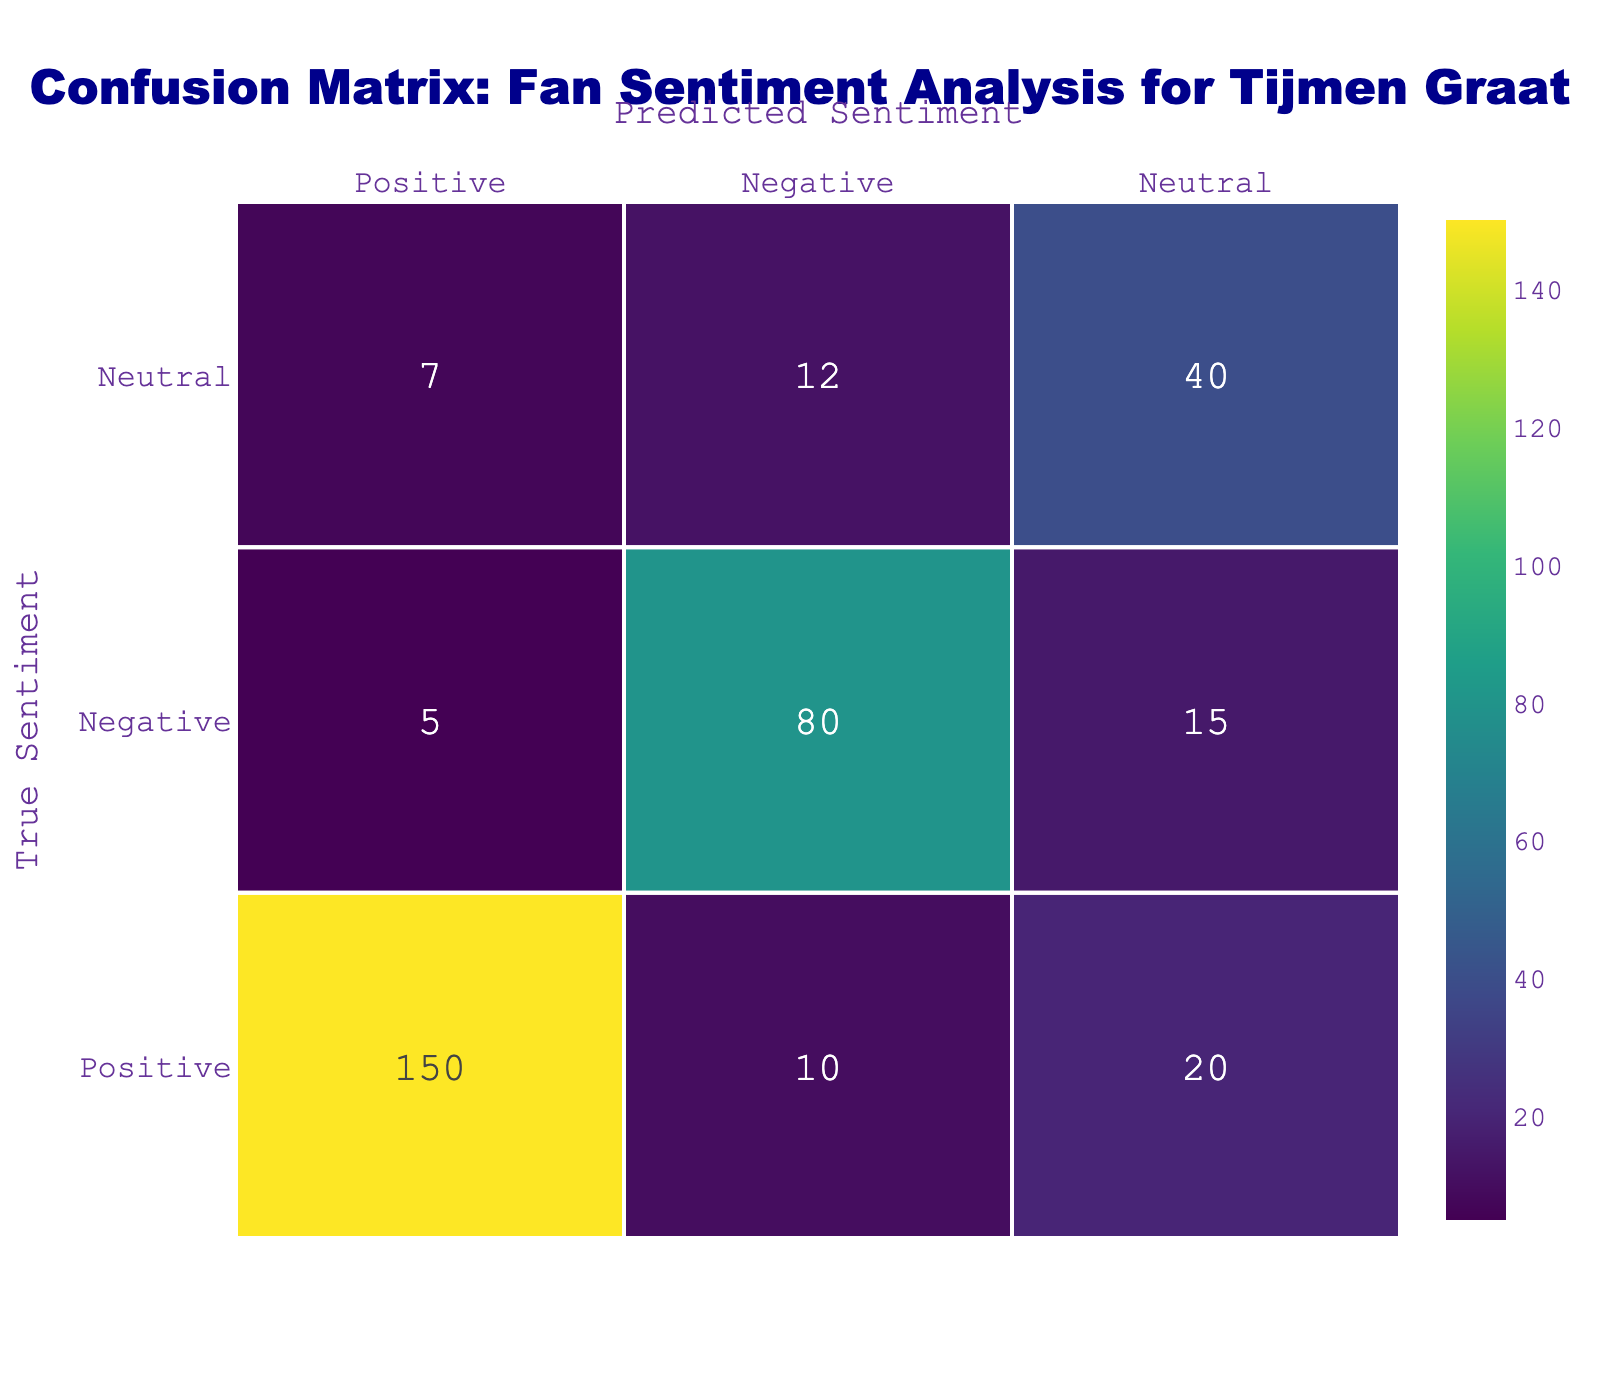What is the frequency of true positive sentiments predicted as positive? From the table, the frequency of instances where the true sentiment is positive and it's also predicted as positive is directly given in the first row under the "Frequency" column, which is 150.
Answer: 150 What is the total number of negative sentiments predicted? To find the total negative predictions, we add the frequencies in the negative prediction column: negative predicted as positive (5), negative predicted as negative (80), and negative predicted as neutral (15), summed gives us (5 + 80 + 15) = 100.
Answer: 100 How many instances were there of positive sentiment predicted as negative? The table shows that there were 10 instances where true positive sentiments were incorrectly predicted as negative, which can be found in the second row of the table.
Answer: 10 Is there a higher frequency of negative sentiments than neutral sentiments in the true positive predictions? Looking at the table, true negative sentiments total (80 + 5 + 15) = 100, while true neutral sentiments total (7 + 12 + 40) = 59. Since 100 > 59, the statement is true.
Answer: Yes What is the overall accuracy of the sentiment predictions? To find the accuracy, we need to sum the true positives (150), true negatives (80), and true neutrals (40) and divide by the total number of predictions. The total number of predictions is (150 + 10 + 20 + 5 + 80 + 15 + 7 + 12 + 40) = 339. The accuracy is (150 + 80 + 40) / 339 = 270 / 339 ≈ 0.797, which is approximately 79.7%.
Answer: Approximately 79.7% 